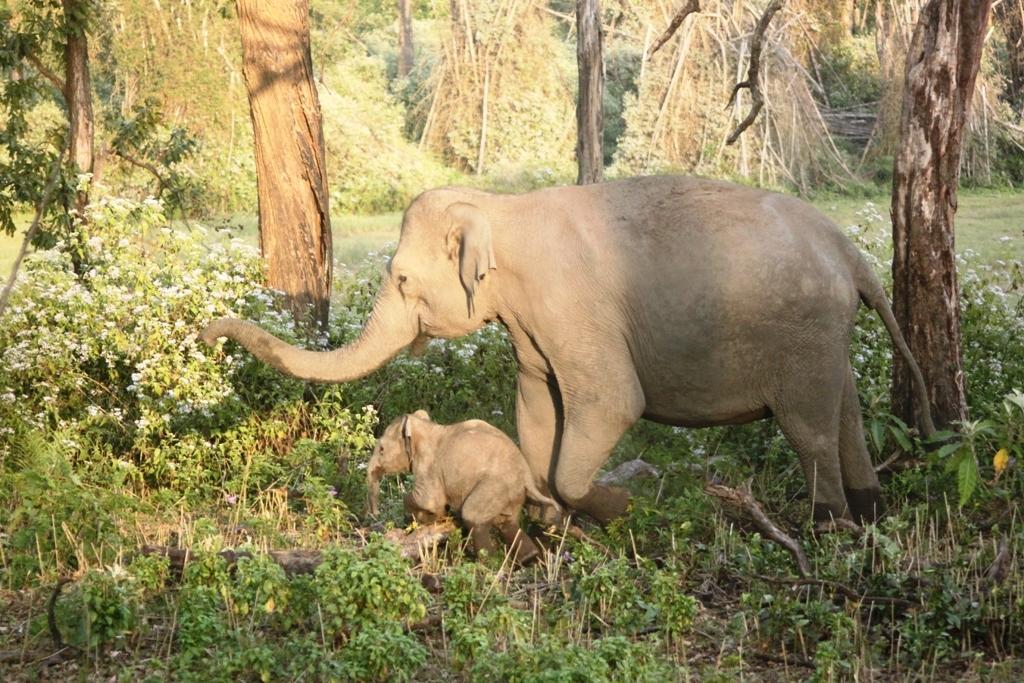Describe this image in one or two sentences. In the center of the image we can see elephant and calf on the ground. In the background we can see trees, grass and plants. 